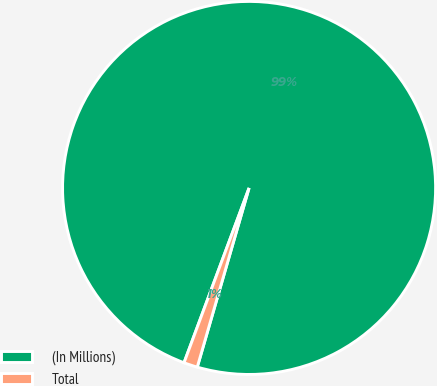Convert chart to OTSL. <chart><loc_0><loc_0><loc_500><loc_500><pie_chart><fcel>(In Millions)<fcel>Total<nl><fcel>98.81%<fcel>1.19%<nl></chart> 